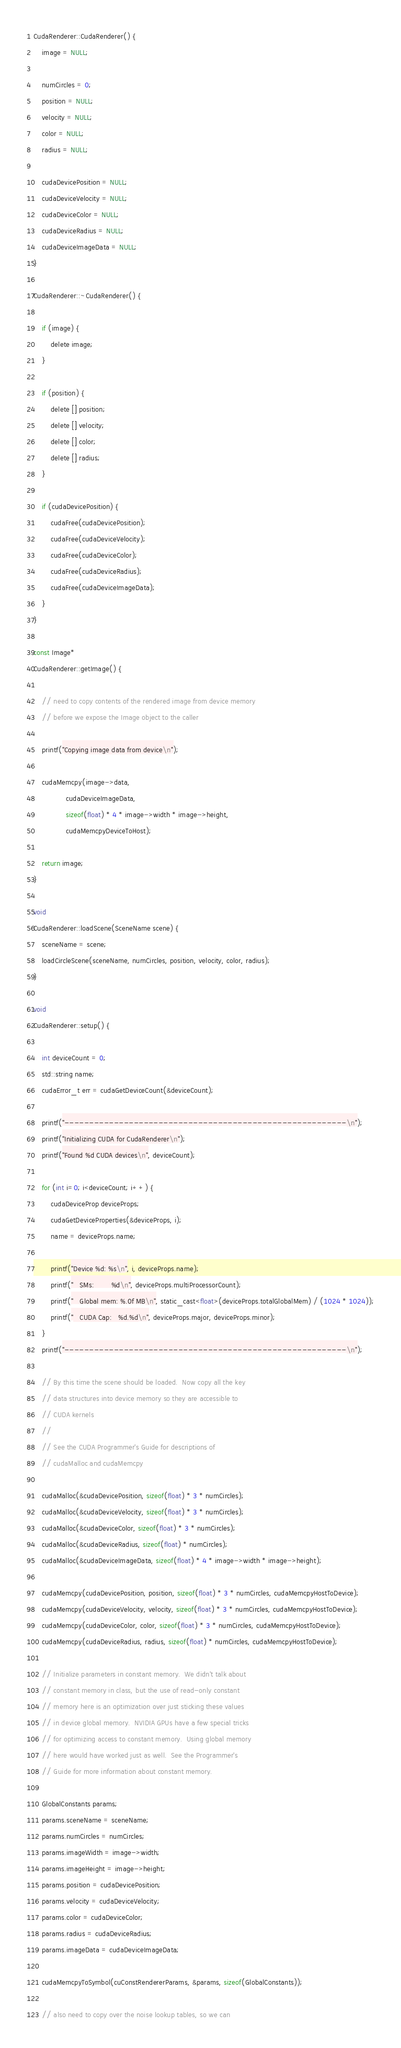Convert code to text. <code><loc_0><loc_0><loc_500><loc_500><_Cuda_>
CudaRenderer::CudaRenderer() {
    image = NULL;

    numCircles = 0;
    position = NULL;
    velocity = NULL;
    color = NULL;
    radius = NULL;

    cudaDevicePosition = NULL;
    cudaDeviceVelocity = NULL;
    cudaDeviceColor = NULL;
    cudaDeviceRadius = NULL;
    cudaDeviceImageData = NULL;
}

CudaRenderer::~CudaRenderer() {

    if (image) {
        delete image;
    }

    if (position) {
        delete [] position;
        delete [] velocity;
        delete [] color;
        delete [] radius;
    }

    if (cudaDevicePosition) {
        cudaFree(cudaDevicePosition);
        cudaFree(cudaDeviceVelocity);
        cudaFree(cudaDeviceColor);
        cudaFree(cudaDeviceRadius);
        cudaFree(cudaDeviceImageData);
    }
}

const Image*
CudaRenderer::getImage() {

    // need to copy contents of the rendered image from device memory
    // before we expose the Image object to the caller

    printf("Copying image data from device\n");

    cudaMemcpy(image->data,
               cudaDeviceImageData,
               sizeof(float) * 4 * image->width * image->height,
               cudaMemcpyDeviceToHost);

    return image;
}

void
CudaRenderer::loadScene(SceneName scene) {
    sceneName = scene;
    loadCircleScene(sceneName, numCircles, position, velocity, color, radius);
}

void
CudaRenderer::setup() {

    int deviceCount = 0;
    std::string name;
    cudaError_t err = cudaGetDeviceCount(&deviceCount);

    printf("---------------------------------------------------------\n");
    printf("Initializing CUDA for CudaRenderer\n");
    printf("Found %d CUDA devices\n", deviceCount);

    for (int i=0; i<deviceCount; i++) {
        cudaDeviceProp deviceProps;
        cudaGetDeviceProperties(&deviceProps, i);
        name = deviceProps.name;

        printf("Device %d: %s\n", i, deviceProps.name);
        printf("   SMs:        %d\n", deviceProps.multiProcessorCount);
        printf("   Global mem: %.0f MB\n", static_cast<float>(deviceProps.totalGlobalMem) / (1024 * 1024));
        printf("   CUDA Cap:   %d.%d\n", deviceProps.major, deviceProps.minor);
    }
    printf("---------------------------------------------------------\n");

    // By this time the scene should be loaded.  Now copy all the key
    // data structures into device memory so they are accessible to
    // CUDA kernels
    //
    // See the CUDA Programmer's Guide for descriptions of
    // cudaMalloc and cudaMemcpy

    cudaMalloc(&cudaDevicePosition, sizeof(float) * 3 * numCircles);
    cudaMalloc(&cudaDeviceVelocity, sizeof(float) * 3 * numCircles);
    cudaMalloc(&cudaDeviceColor, sizeof(float) * 3 * numCircles);
    cudaMalloc(&cudaDeviceRadius, sizeof(float) * numCircles);
    cudaMalloc(&cudaDeviceImageData, sizeof(float) * 4 * image->width * image->height);

    cudaMemcpy(cudaDevicePosition, position, sizeof(float) * 3 * numCircles, cudaMemcpyHostToDevice);
    cudaMemcpy(cudaDeviceVelocity, velocity, sizeof(float) * 3 * numCircles, cudaMemcpyHostToDevice);
    cudaMemcpy(cudaDeviceColor, color, sizeof(float) * 3 * numCircles, cudaMemcpyHostToDevice);
    cudaMemcpy(cudaDeviceRadius, radius, sizeof(float) * numCircles, cudaMemcpyHostToDevice);

    // Initialize parameters in constant memory.  We didn't talk about
    // constant memory in class, but the use of read-only constant
    // memory here is an optimization over just sticking these values
    // in device global memory.  NVIDIA GPUs have a few special tricks
    // for optimizing access to constant memory.  Using global memory
    // here would have worked just as well.  See the Programmer's
    // Guide for more information about constant memory.

    GlobalConstants params;
    params.sceneName = sceneName;
    params.numCircles = numCircles;
    params.imageWidth = image->width;
    params.imageHeight = image->height;
    params.position = cudaDevicePosition;
    params.velocity = cudaDeviceVelocity;
    params.color = cudaDeviceColor;
    params.radius = cudaDeviceRadius;
    params.imageData = cudaDeviceImageData;

    cudaMemcpyToSymbol(cuConstRendererParams, &params, sizeof(GlobalConstants));

    // also need to copy over the noise lookup tables, so we can</code> 